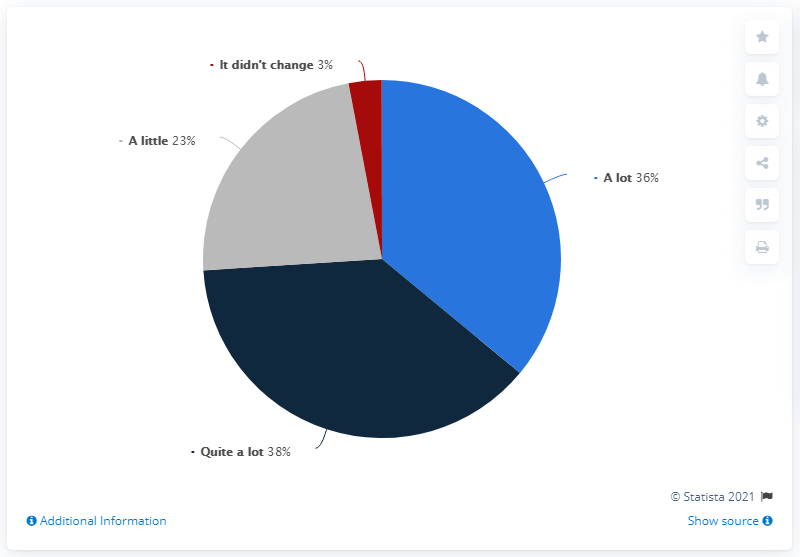Outline some significant characteristics in this image. The smallest segment is red. The result of dividing the second-largest segment by the smallest segment is 12. 